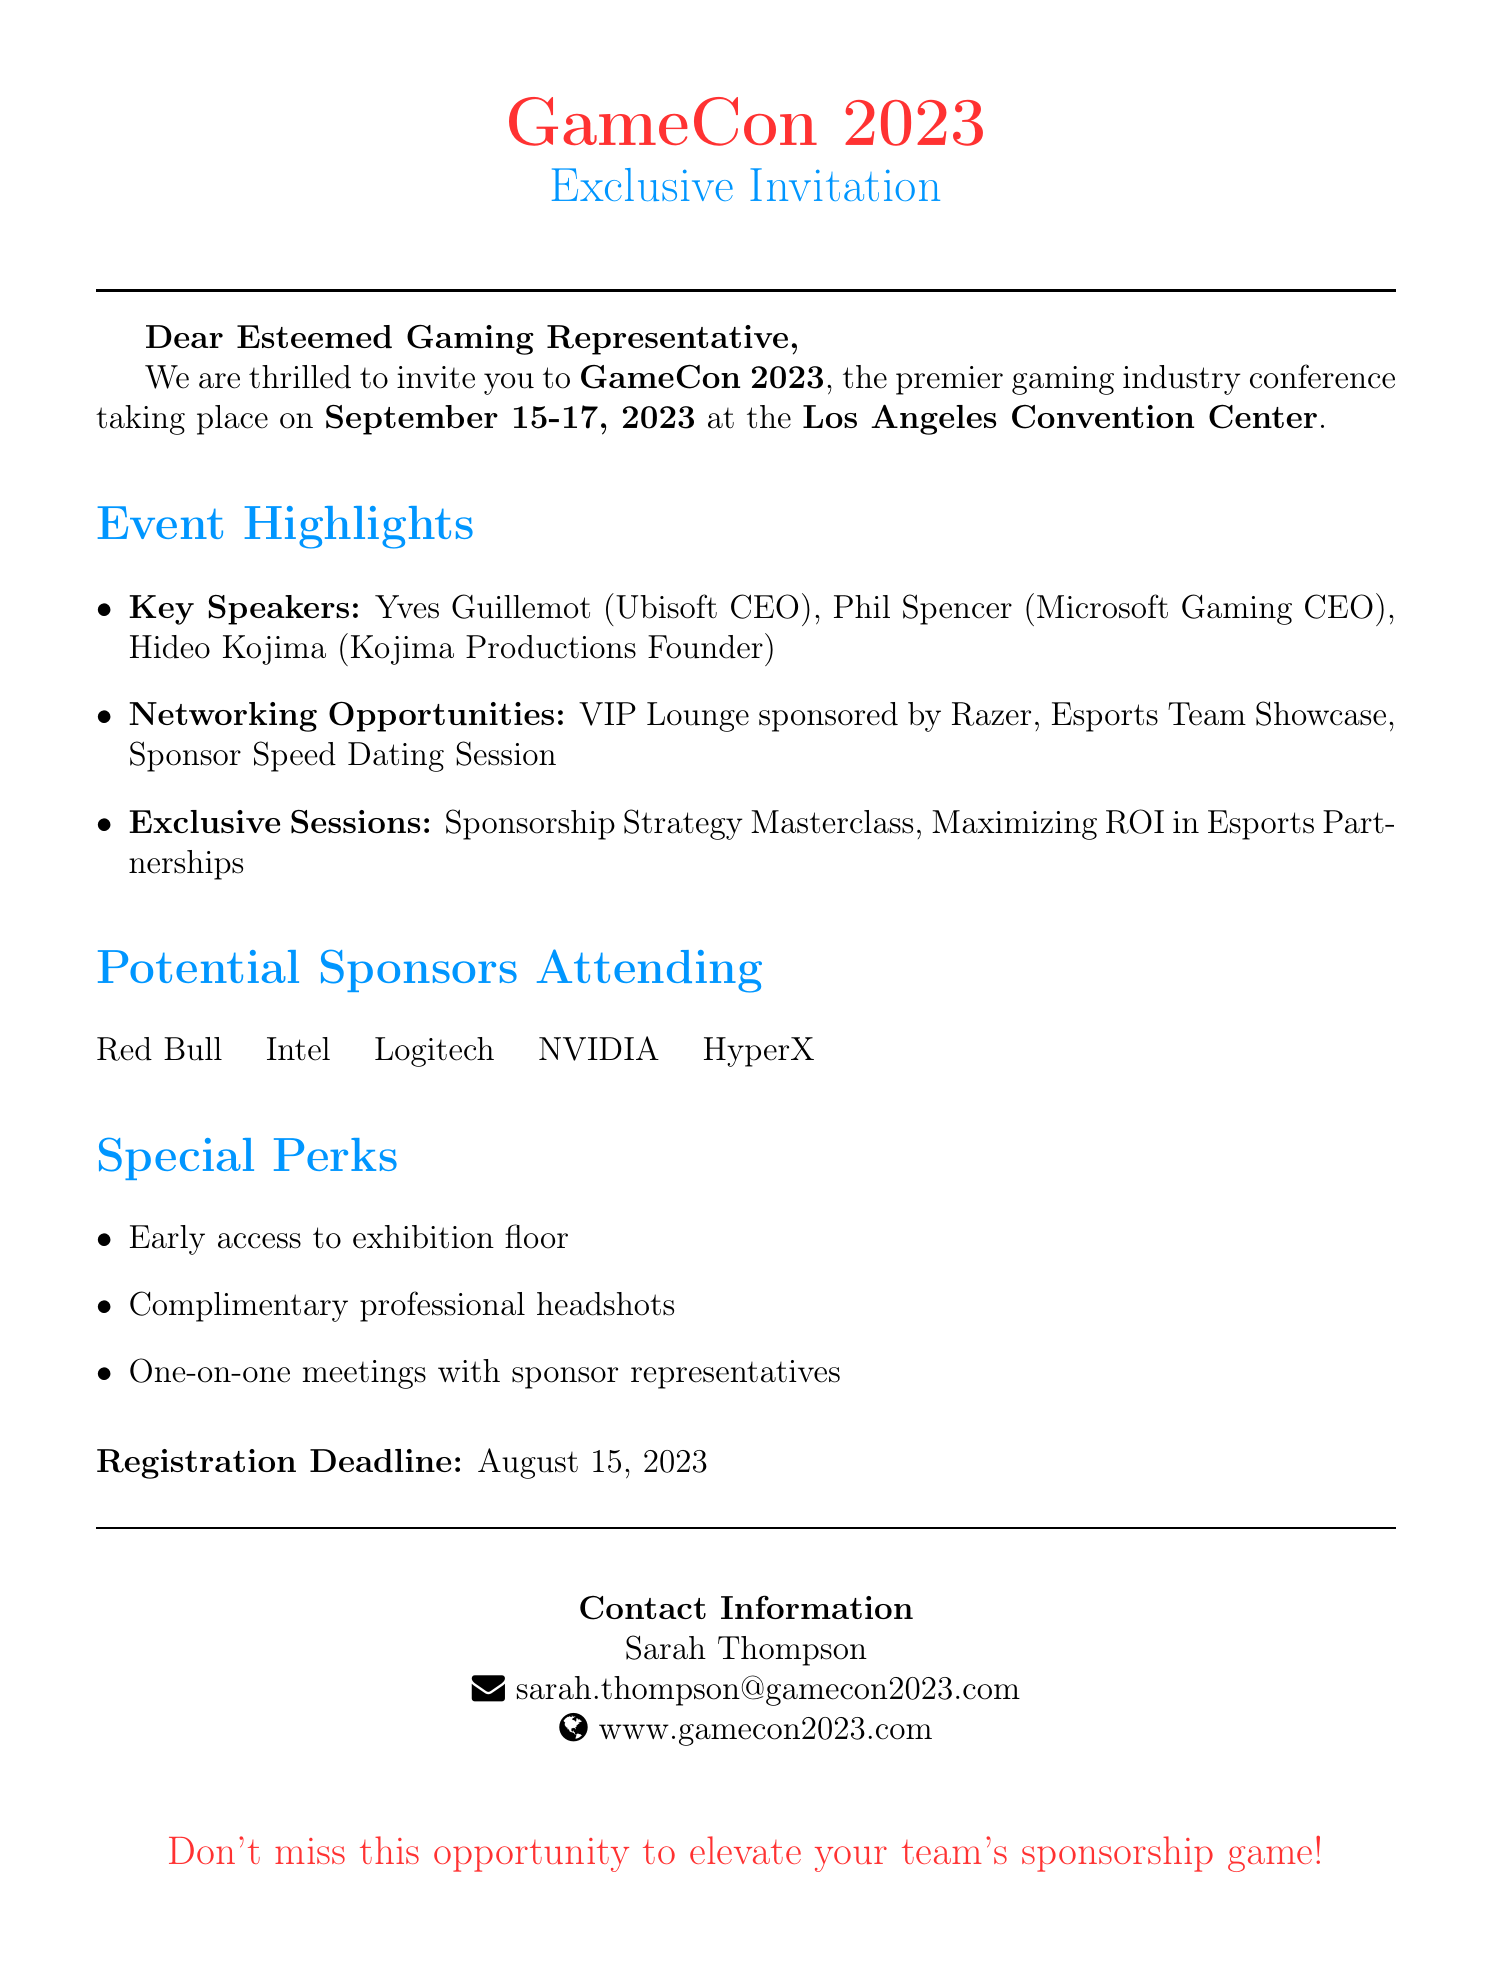What are the dates of GameCon 2023? The dates of GameCon 2023 are specified clearly in the document as September 15-17, 2023.
Answer: September 15-17, 2023 Who is the contact person for the event? The contact person for the event is mentioned in the contact information section of the document.
Answer: Sarah Thompson Which company is sponsoring the VIP Lounge? The document highlights the VIP Lounge sponsorship specifically by Razer.
Answer: Razer What are the names of the key speakers? The document lists the key speakers under the event highlights section, showing their names and affiliations.
Answer: Yves Guillemot, Phil Spencer, Hideo Kojima What is one of the special perks offered at the conference? The document outlines special perks, including early access to the exhibition floor, as one example.
Answer: Early access to exhibition floor How many potential sponsors are listed in the document? The document lists a total of five potential sponsors attending the event.
Answer: Five 